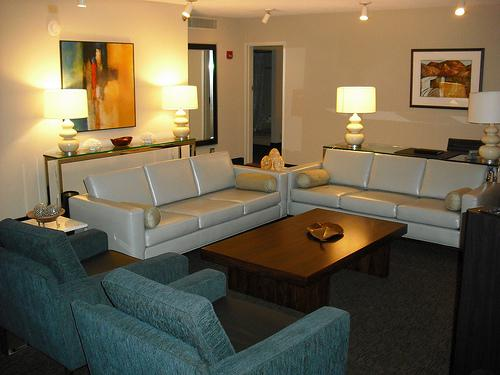Question: where was the image taken?
Choices:
A. In a living room.
B. A kitchen.
C. A bathroom.
D. A restaurant.
Answer with the letter. Answer: A Question: how many lamps are in the image?
Choices:
A. Three.
B. Two.
C. Four.
D. One.
Answer with the letter. Answer: C Question: who is in the image?
Choices:
A. The president.
B. Soldiers.
C. There are no people in the image.
D. Sailors.
Answer with the letter. Answer: C Question: where is the coffee table?
Choices:
A. Next to the counter.
B. In the center of the room.
C. Kitchen.
D. Living room.
Answer with the letter. Answer: B 